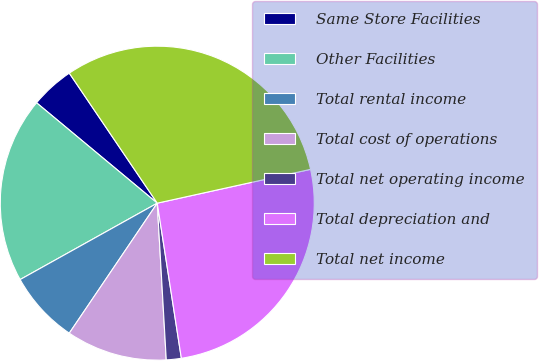<chart> <loc_0><loc_0><loc_500><loc_500><pie_chart><fcel>Same Store Facilities<fcel>Other Facilities<fcel>Total rental income<fcel>Total cost of operations<fcel>Total net operating income<fcel>Total depreciation and<fcel>Total net income<nl><fcel>4.49%<fcel>19.13%<fcel>7.44%<fcel>10.38%<fcel>1.54%<fcel>26.0%<fcel>31.01%<nl></chart> 